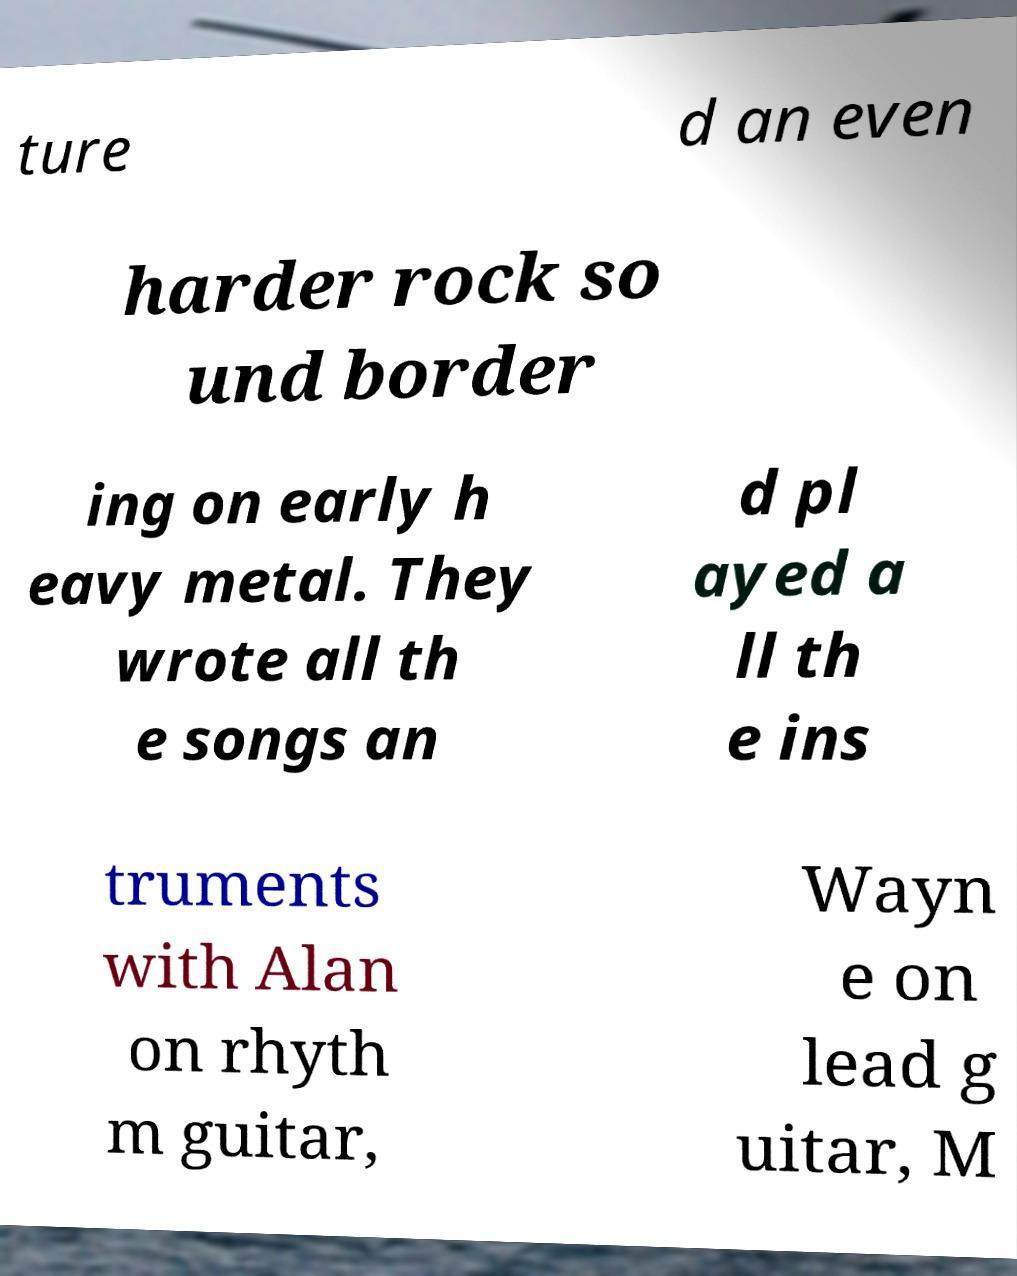Could you extract and type out the text from this image? ture d an even harder rock so und border ing on early h eavy metal. They wrote all th e songs an d pl ayed a ll th e ins truments with Alan on rhyth m guitar, Wayn e on lead g uitar, M 